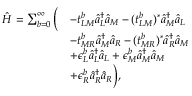<formula> <loc_0><loc_0><loc_500><loc_500>\begin{array} { r l } { \hat { H } = \sum _ { b = 0 } ^ { \infty } \left ( } & { - t _ { L M } ^ { b } \hat { a } _ { L } ^ { \dagger } \hat { a } _ { M } - ( t _ { L M } ^ { b } ) ^ { * } \hat { a } _ { M } ^ { \dagger } \hat { a } _ { L } } \\ & { - t _ { M R } ^ { b } \hat { a } _ { M } ^ { \dagger } \hat { a } _ { R } - ( t _ { M R } ^ { b } ) ^ { * } \hat { a } _ { R } ^ { \dagger } \hat { a } _ { M } } \\ & { + \epsilon _ { L } ^ { b } \hat { a } _ { L } ^ { \dagger } \hat { a } _ { L } + \epsilon _ { M } ^ { b } \hat { a } _ { M } ^ { \dagger } \hat { a } _ { M } } \\ & { + \epsilon _ { R } ^ { b } \hat { a } _ { R } ^ { \dagger } \hat { a } _ { R } \right ) , } \end{array}</formula> 